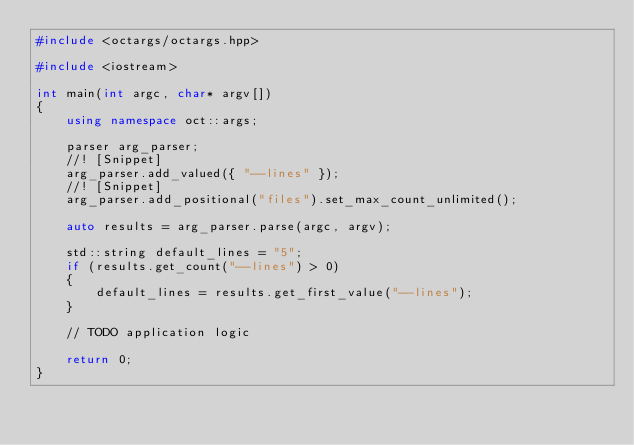<code> <loc_0><loc_0><loc_500><loc_500><_C++_>#include <octargs/octargs.hpp>

#include <iostream>

int main(int argc, char* argv[])
{
    using namespace oct::args;

    parser arg_parser;
    //! [Snippet]
    arg_parser.add_valued({ "--lines" });
    //! [Snippet]
    arg_parser.add_positional("files").set_max_count_unlimited();

    auto results = arg_parser.parse(argc, argv);

    std::string default_lines = "5";
    if (results.get_count("--lines") > 0)
    {
        default_lines = results.get_first_value("--lines");
    }

    // TODO application logic

    return 0;
}
</code> 